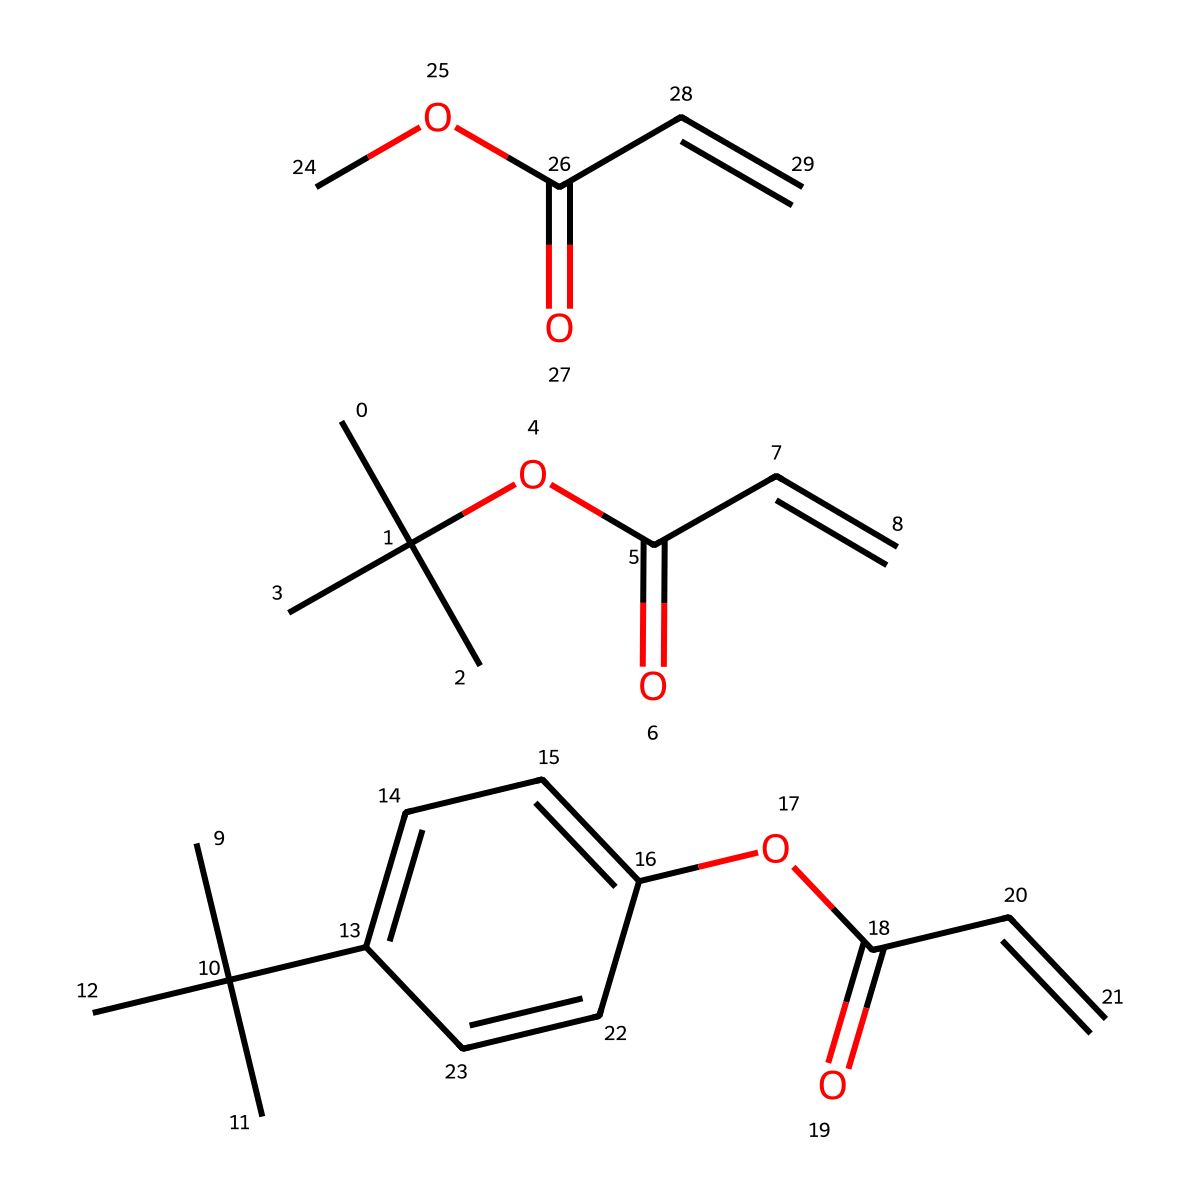What is the molecular formula of the photoresist from the SMILES? By interpreting the SMILES and counting the carbon (C), hydrogen (H), and oxygen (O) atoms, we can deduce the molecular formula. The shorthand notation suggests a high degree of branching and aromaticity, which we account for while counting. The overall observed count gives us C18H28O4.
Answer: C18H28O4 How many rings are present in this chemical structure? Analyzing the structure, we note the presence of cyclohexane-like structures, identifying one benzene ring. The branching also indicates additional circular connectivity. Therefore, we conclude there is one ring in total.
Answer: 1 What type of functional groups are present in this photoresist? The analysis shows the presence of ester groups (due to “OC(=O)” notation) and aromatic rings (indicated by the double bonds and cyclic structure). The ester functionality is crucial for the properties of photoresists.
Answer: ester and aromatic What type of reaction would this photoresist likely undergo during exposure? Given the presence of unsaturated bonds (C=C) in the structure, it is likely to undergo polymerization or cross-linking upon exposure to UV light, a common characteristic of photoresists in lithography.
Answer: polymerization How does the structure of this photoresist contribute to its light sensitivity? The presence of unsaturated bonds (C=C) allows for photo-induced reactions upon light exposure, making the material sensitive to certain wavelengths. Additionally, the degree of conjugation from the aromatic systems enhances its light absorption characteristics.
Answer: unsaturation and conjugation 